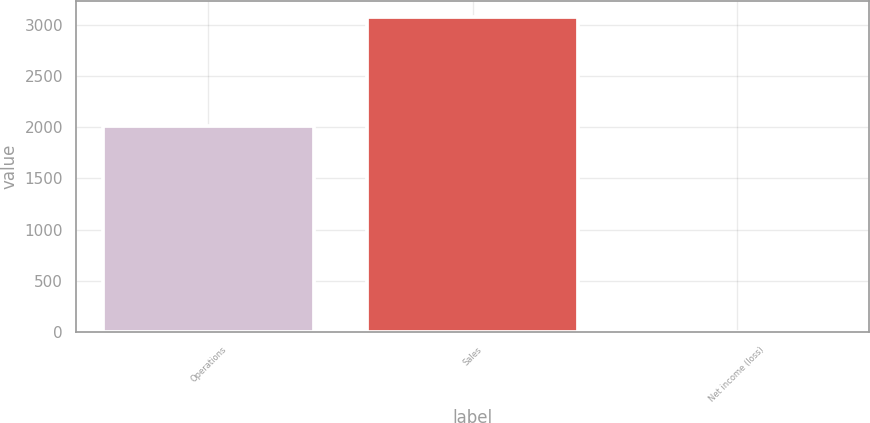Convert chart to OTSL. <chart><loc_0><loc_0><loc_500><loc_500><bar_chart><fcel>Operations<fcel>Sales<fcel>Net income (loss)<nl><fcel>2014<fcel>3082<fcel>1<nl></chart> 